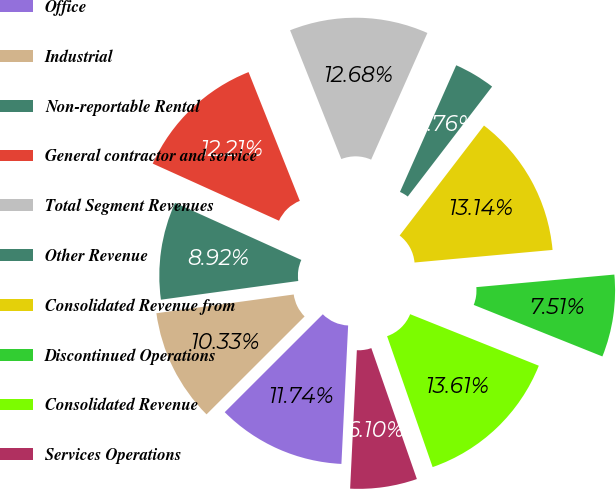<chart> <loc_0><loc_0><loc_500><loc_500><pie_chart><fcel>Office<fcel>Industrial<fcel>Non-reportable Rental<fcel>General contractor and service<fcel>Total Segment Revenues<fcel>Other Revenue<fcel>Consolidated Revenue from<fcel>Discontinued Operations<fcel>Consolidated Revenue<fcel>Services Operations<nl><fcel>11.74%<fcel>10.33%<fcel>8.92%<fcel>12.21%<fcel>12.68%<fcel>3.76%<fcel>13.14%<fcel>7.51%<fcel>13.61%<fcel>6.1%<nl></chart> 